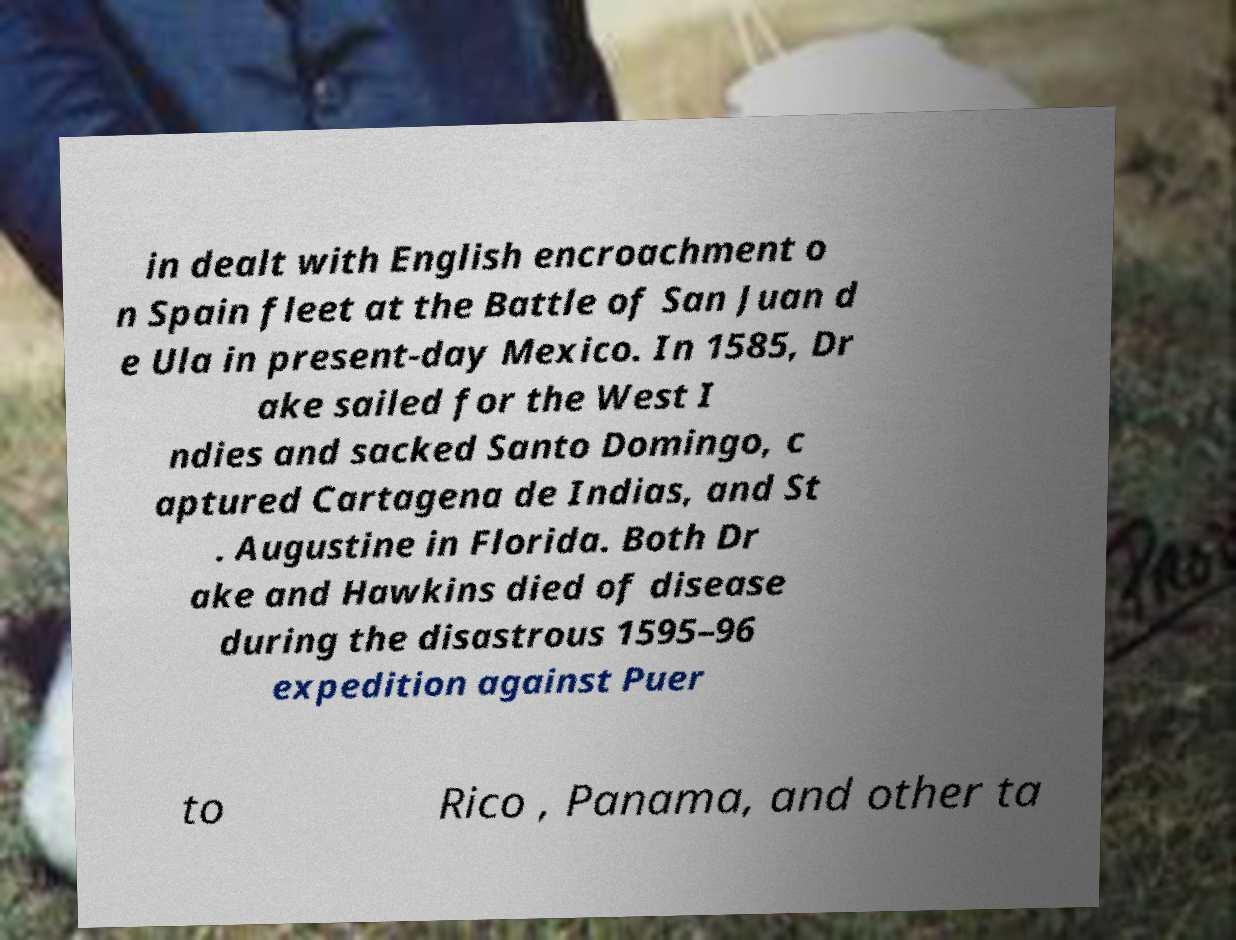Can you accurately transcribe the text from the provided image for me? in dealt with English encroachment o n Spain fleet at the Battle of San Juan d e Ula in present-day Mexico. In 1585, Dr ake sailed for the West I ndies and sacked Santo Domingo, c aptured Cartagena de Indias, and St . Augustine in Florida. Both Dr ake and Hawkins died of disease during the disastrous 1595–96 expedition against Puer to Rico , Panama, and other ta 